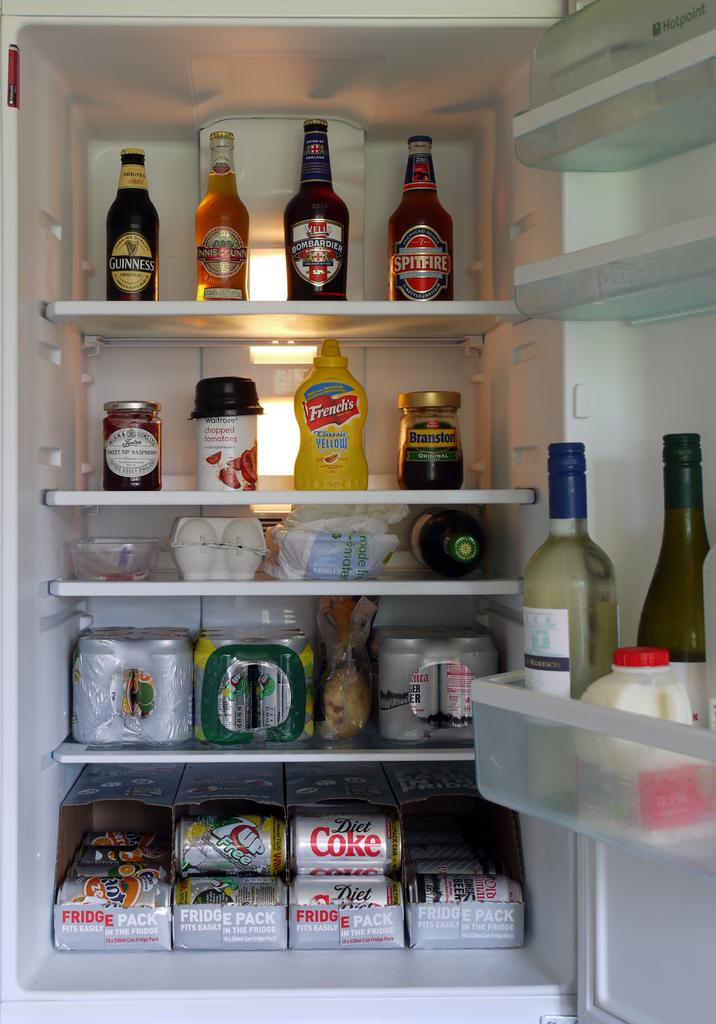What type of appliance is visible in the image? There is a fridge in the image. What items can be found inside the fridge? Inside the fridge, there are bottles, an egg box, cans, a bowl, and packets. Can you describe the contents of the egg box? The egg box contains eggs, as it is designed to hold and organize them. What might be the purpose of the bowl inside the fridge? The bowl inside the fridge could be used for storing or serving food items. Can you see any roots growing inside the fridge in the image? No, there are no roots visible inside the fridge in the image. Is there a mountain visible inside the fridge in the image? No, there is no mountain visible inside the fridge in the image. 